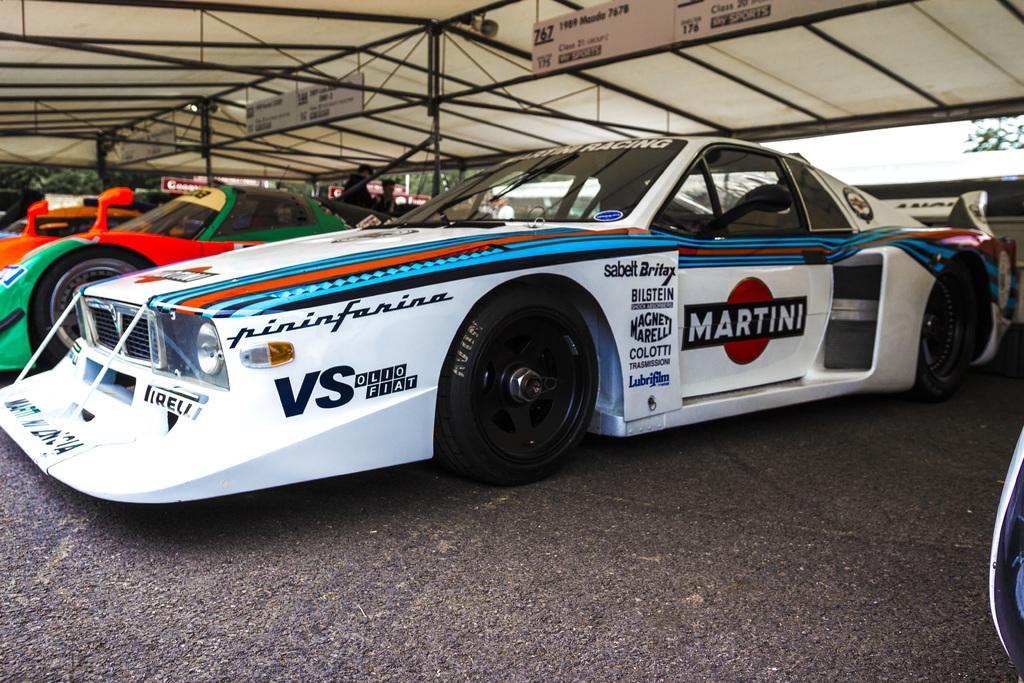How would you summarize this image in a sentence or two? In this image we can see the people standing and there is the tent and there are boards attached to the rod. And there are vehicles on the road and the sky. 